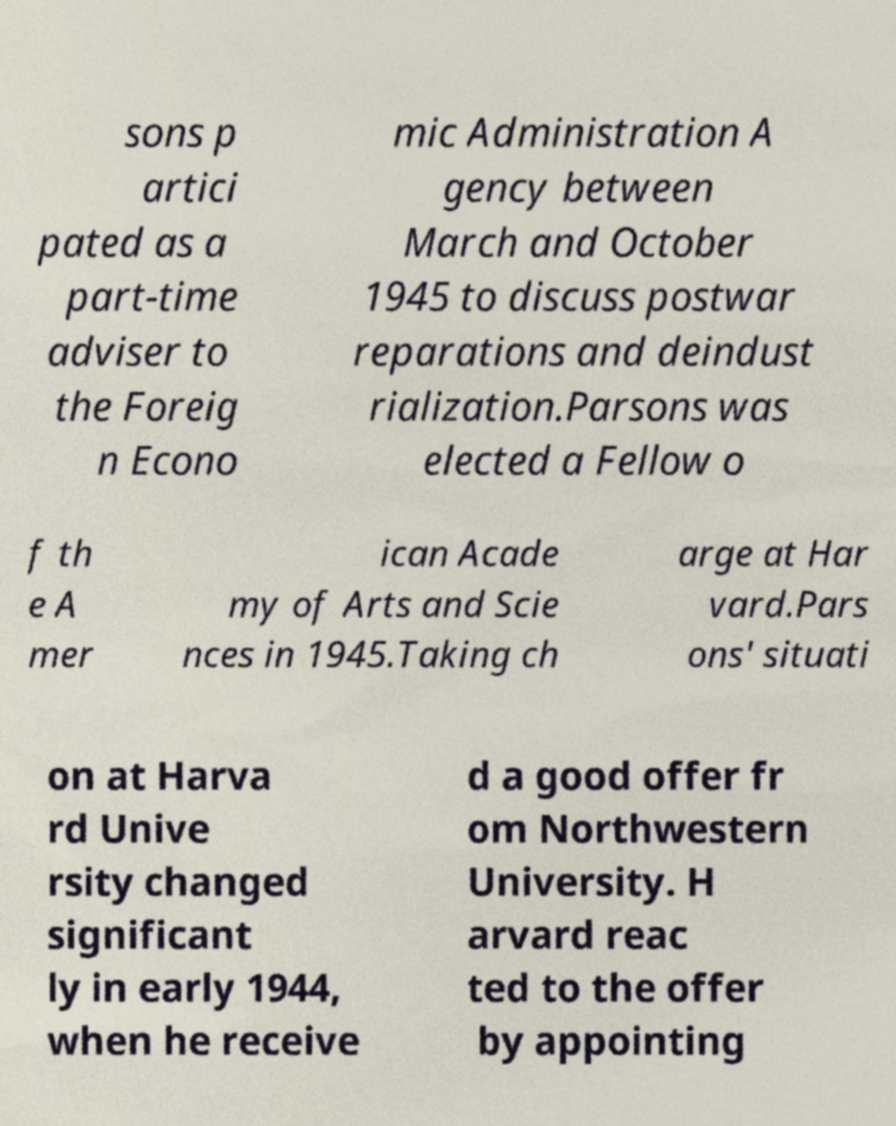I need the written content from this picture converted into text. Can you do that? sons p artici pated as a part-time adviser to the Foreig n Econo mic Administration A gency between March and October 1945 to discuss postwar reparations and deindust rialization.Parsons was elected a Fellow o f th e A mer ican Acade my of Arts and Scie nces in 1945.Taking ch arge at Har vard.Pars ons' situati on at Harva rd Unive rsity changed significant ly in early 1944, when he receive d a good offer fr om Northwestern University. H arvard reac ted to the offer by appointing 